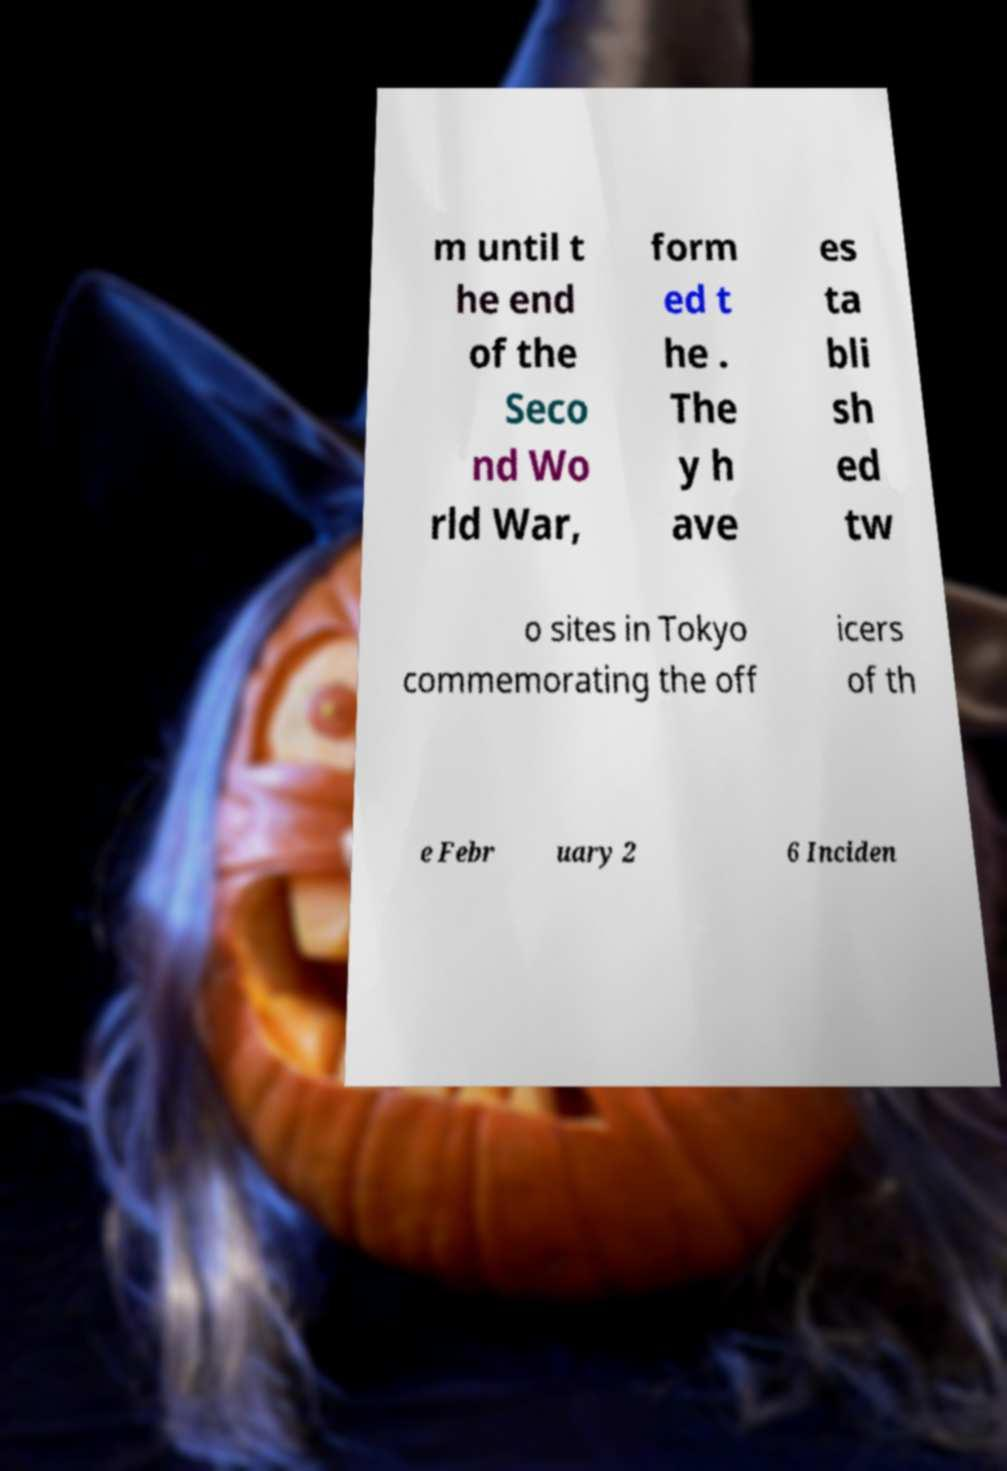Could you assist in decoding the text presented in this image and type it out clearly? m until t he end of the Seco nd Wo rld War, form ed t he . The y h ave es ta bli sh ed tw o sites in Tokyo commemorating the off icers of th e Febr uary 2 6 Inciden 